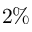<formula> <loc_0><loc_0><loc_500><loc_500>2 \%</formula> 